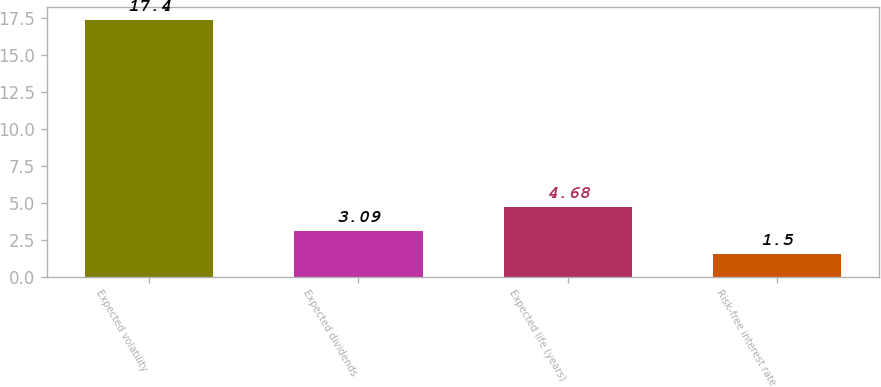Convert chart. <chart><loc_0><loc_0><loc_500><loc_500><bar_chart><fcel>Expected volatility<fcel>Expected dividends<fcel>Expected life (years)<fcel>Risk-free interest rate<nl><fcel>17.4<fcel>3.09<fcel>4.68<fcel>1.5<nl></chart> 